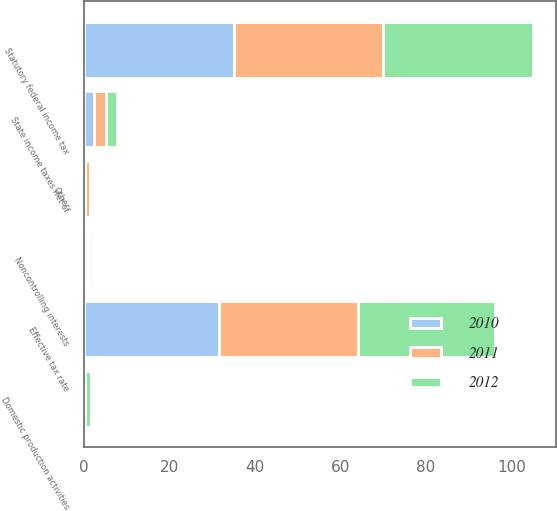<chart> <loc_0><loc_0><loc_500><loc_500><stacked_bar_chart><ecel><fcel>Statutory federal income tax<fcel>State income taxes net of<fcel>Noncontrolling interests<fcel>Domestic production activities<fcel>Other<fcel>Effective tax rate<nl><fcel>2012<fcel>35<fcel>2.5<fcel>0.6<fcel>1.6<fcel>0.4<fcel>32.2<nl><fcel>2011<fcel>35<fcel>2.7<fcel>0.6<fcel>0.1<fcel>1.2<fcel>32.4<nl><fcel>2010<fcel>35<fcel>2.5<fcel>0.7<fcel>0.1<fcel>0.2<fcel>31.6<nl></chart> 